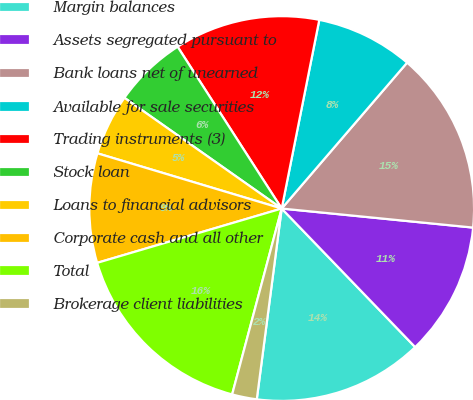<chart> <loc_0><loc_0><loc_500><loc_500><pie_chart><fcel>Margin balances<fcel>Assets segregated pursuant to<fcel>Bank loans net of unearned<fcel>Available for sale securities<fcel>Trading instruments (3)<fcel>Stock loan<fcel>Loans to financial advisors<fcel>Corporate cash and all other<fcel>Total<fcel>Brokerage client liabilities<nl><fcel>14.27%<fcel>11.22%<fcel>15.28%<fcel>8.17%<fcel>12.23%<fcel>6.14%<fcel>5.13%<fcel>9.19%<fcel>16.3%<fcel>2.08%<nl></chart> 